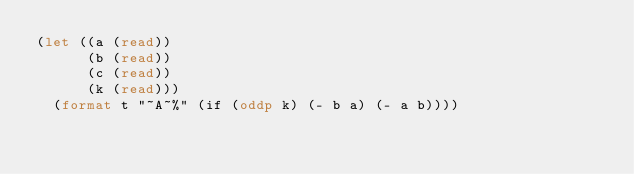Convert code to text. <code><loc_0><loc_0><loc_500><loc_500><_Lisp_>(let ((a (read))
      (b (read))
      (c (read))
      (k (read)))
  (format t "~A~%" (if (oddp k) (- b a) (- a b))))
</code> 